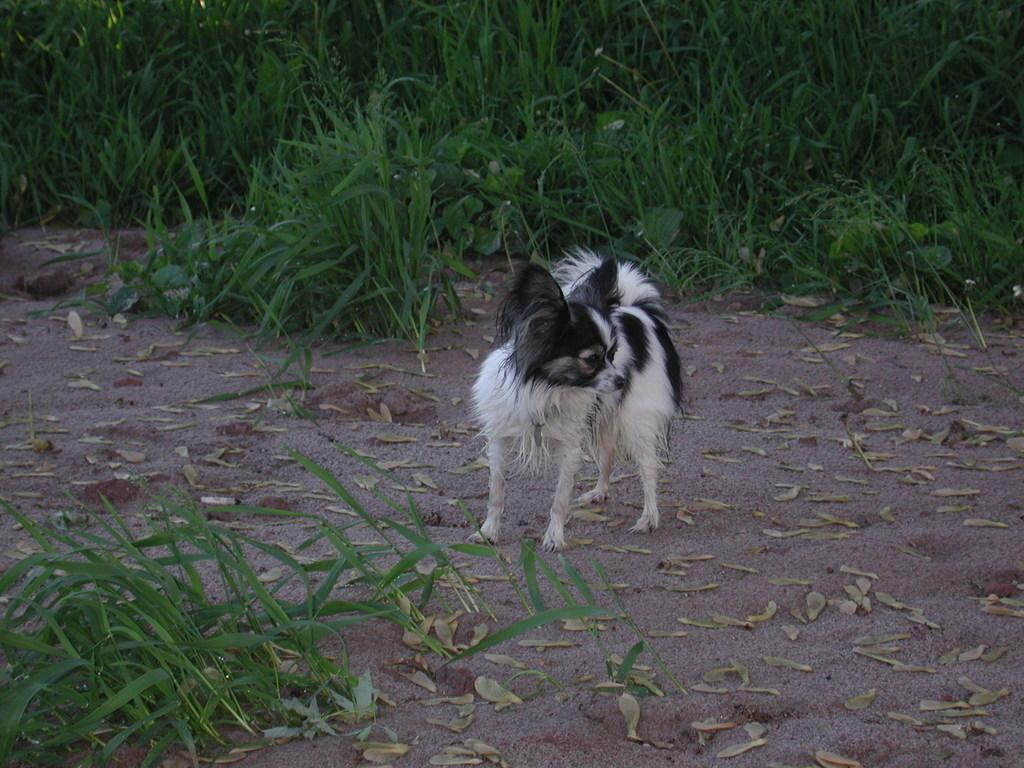What animal is present in the image? There is a dog in the image. Can you describe the color of the dog? The dog is white and black in color. What is the dog doing in the image? The dog is standing on the ground. What type of vegetation can be seen in the image? There is grass in the front and background of the image. How many sheep are visible in the image? There are no sheep present in the image. Is there a balloon floating above the dog in the image? There is no balloon present in the image. 